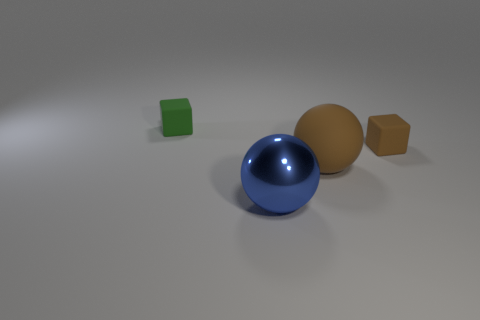What is the color of the matte object in front of the rubber cube that is right of the big blue metallic thing?
Ensure brevity in your answer.  Brown. What shape is the other object that is the same size as the metallic thing?
Give a very brief answer. Sphere. The tiny rubber object that is the same color as the large matte thing is what shape?
Offer a very short reply. Cube. Are there the same number of small objects in front of the tiny brown rubber cube and small brown matte cubes?
Provide a succinct answer. No. What is the material of the tiny cube behind the tiny cube that is on the right side of the green cube that is behind the big brown sphere?
Make the answer very short. Rubber. What shape is the green object that is made of the same material as the brown sphere?
Provide a short and direct response. Cube. Are there any other things that have the same color as the large metallic object?
Offer a very short reply. No. There is a brown thing that is left of the small thing on the right side of the green matte cube; what number of big matte things are to the left of it?
Make the answer very short. 0. How many green objects are rubber cubes or cylinders?
Keep it short and to the point. 1. Do the green thing and the cube that is in front of the tiny green rubber object have the same size?
Keep it short and to the point. Yes. 